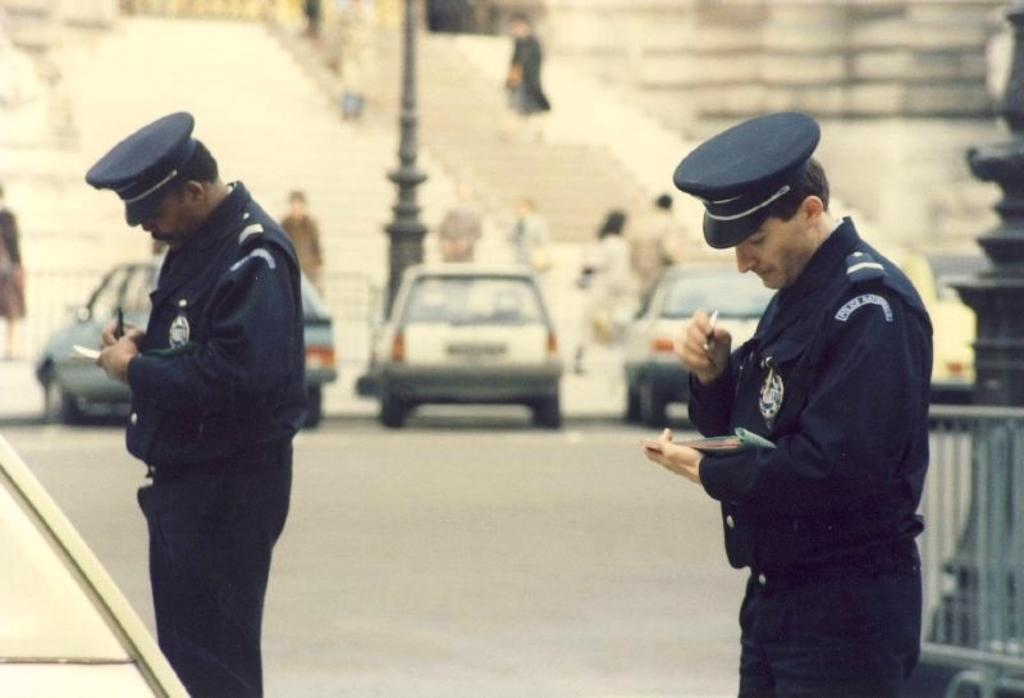Who or what can be seen in the image? There are people and vehicles in the image. What is the surface that the people and vehicles are on? The ground is visible in the image. What structures are present in the image? There are poles, an object on the right side of the image, stairs, and a wall in the image. What color is the sister's scarf in the middle of the image? There is no sister or scarf present in the image. 